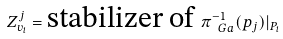<formula> <loc_0><loc_0><loc_500><loc_500>Z _ { v _ { i } } ^ { j } = \text {stabilizer of } \pi _ { \ G a } ^ { - 1 } ( p _ { j } ) | _ { P _ { i } }</formula> 